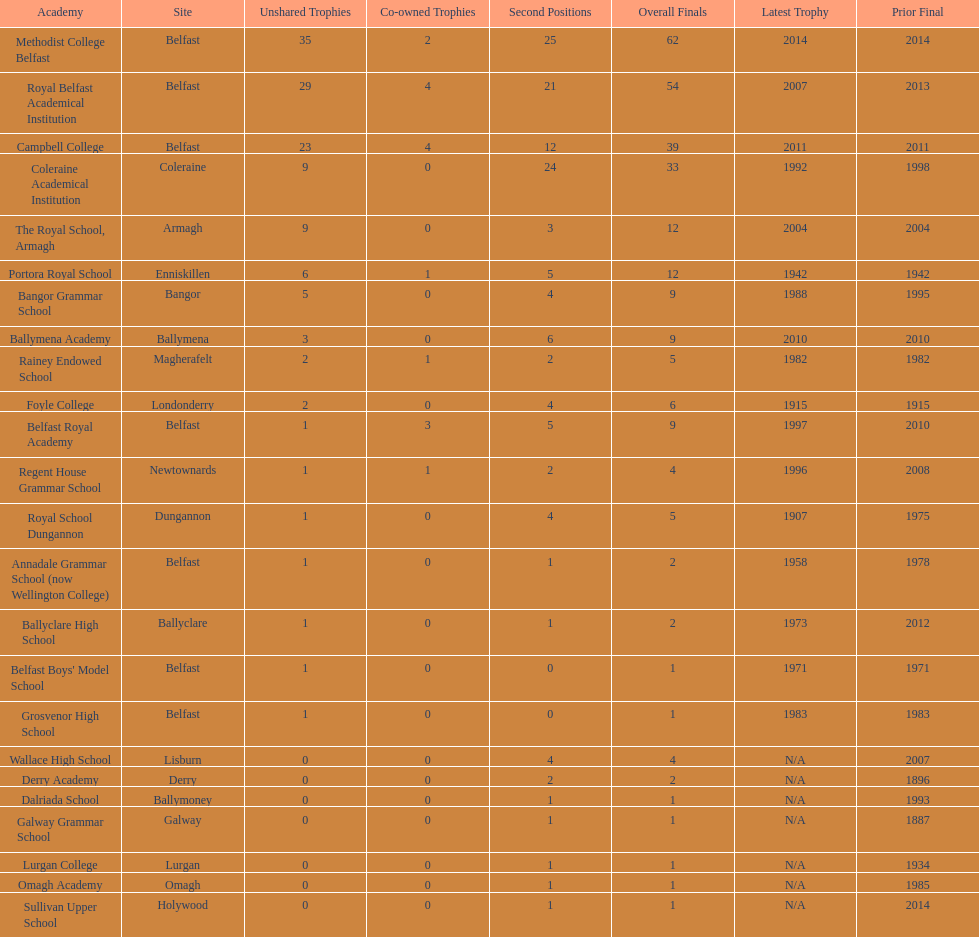Did belfast royal academy have more or less total finals than ballyclare high school? More. 